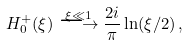<formula> <loc_0><loc_0><loc_500><loc_500>H _ { 0 } ^ { + } ( \xi ) \stackrel { \xi \ll 1 } { \longrightarrow } \frac { 2 i } { \pi } \ln ( \xi / 2 ) \, ,</formula> 